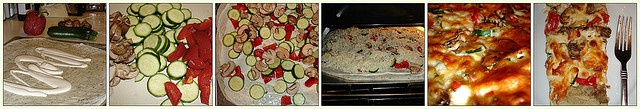Describe the objects in this image and their specific colors. I can see pizza in beige, maroon, brown, and red tones, pizza in beige, brown, tan, and maroon tones, oven in beige, black, gray, and darkgray tones, and fork in beige, black, gray, and maroon tones in this image. 